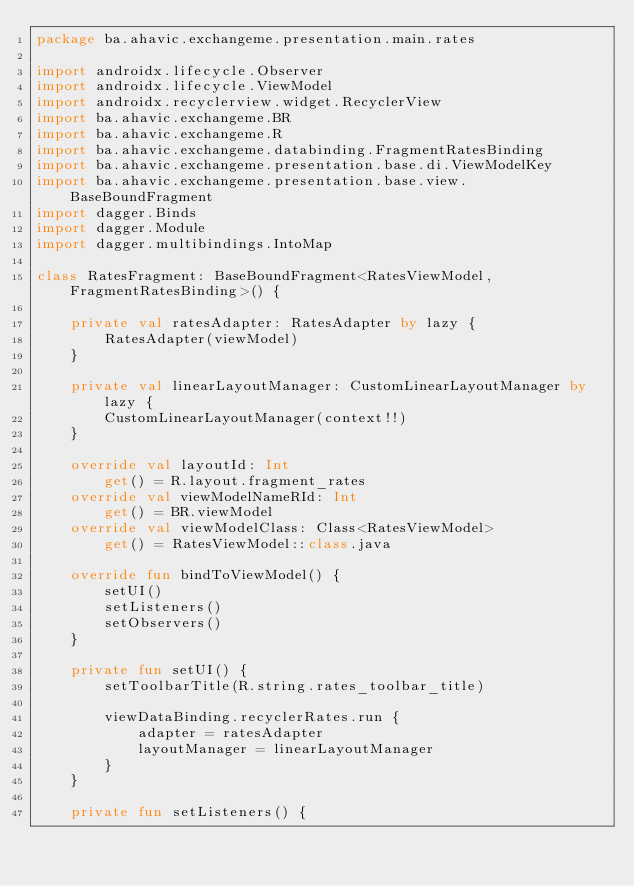Convert code to text. <code><loc_0><loc_0><loc_500><loc_500><_Kotlin_>package ba.ahavic.exchangeme.presentation.main.rates

import androidx.lifecycle.Observer
import androidx.lifecycle.ViewModel
import androidx.recyclerview.widget.RecyclerView
import ba.ahavic.exchangeme.BR
import ba.ahavic.exchangeme.R
import ba.ahavic.exchangeme.databinding.FragmentRatesBinding
import ba.ahavic.exchangeme.presentation.base.di.ViewModelKey
import ba.ahavic.exchangeme.presentation.base.view.BaseBoundFragment
import dagger.Binds
import dagger.Module
import dagger.multibindings.IntoMap

class RatesFragment: BaseBoundFragment<RatesViewModel, FragmentRatesBinding>() {

    private val ratesAdapter: RatesAdapter by lazy {
        RatesAdapter(viewModel)
    }

    private val linearLayoutManager: CustomLinearLayoutManager by lazy {
        CustomLinearLayoutManager(context!!)
    }

    override val layoutId: Int
        get() = R.layout.fragment_rates
    override val viewModelNameRId: Int
        get() = BR.viewModel
    override val viewModelClass: Class<RatesViewModel>
        get() = RatesViewModel::class.java

    override fun bindToViewModel() {
        setUI()
        setListeners()
        setObservers()
    }

    private fun setUI() {
        setToolbarTitle(R.string.rates_toolbar_title)

        viewDataBinding.recyclerRates.run {
            adapter = ratesAdapter
            layoutManager = linearLayoutManager
        }
    }

    private fun setListeners() {</code> 